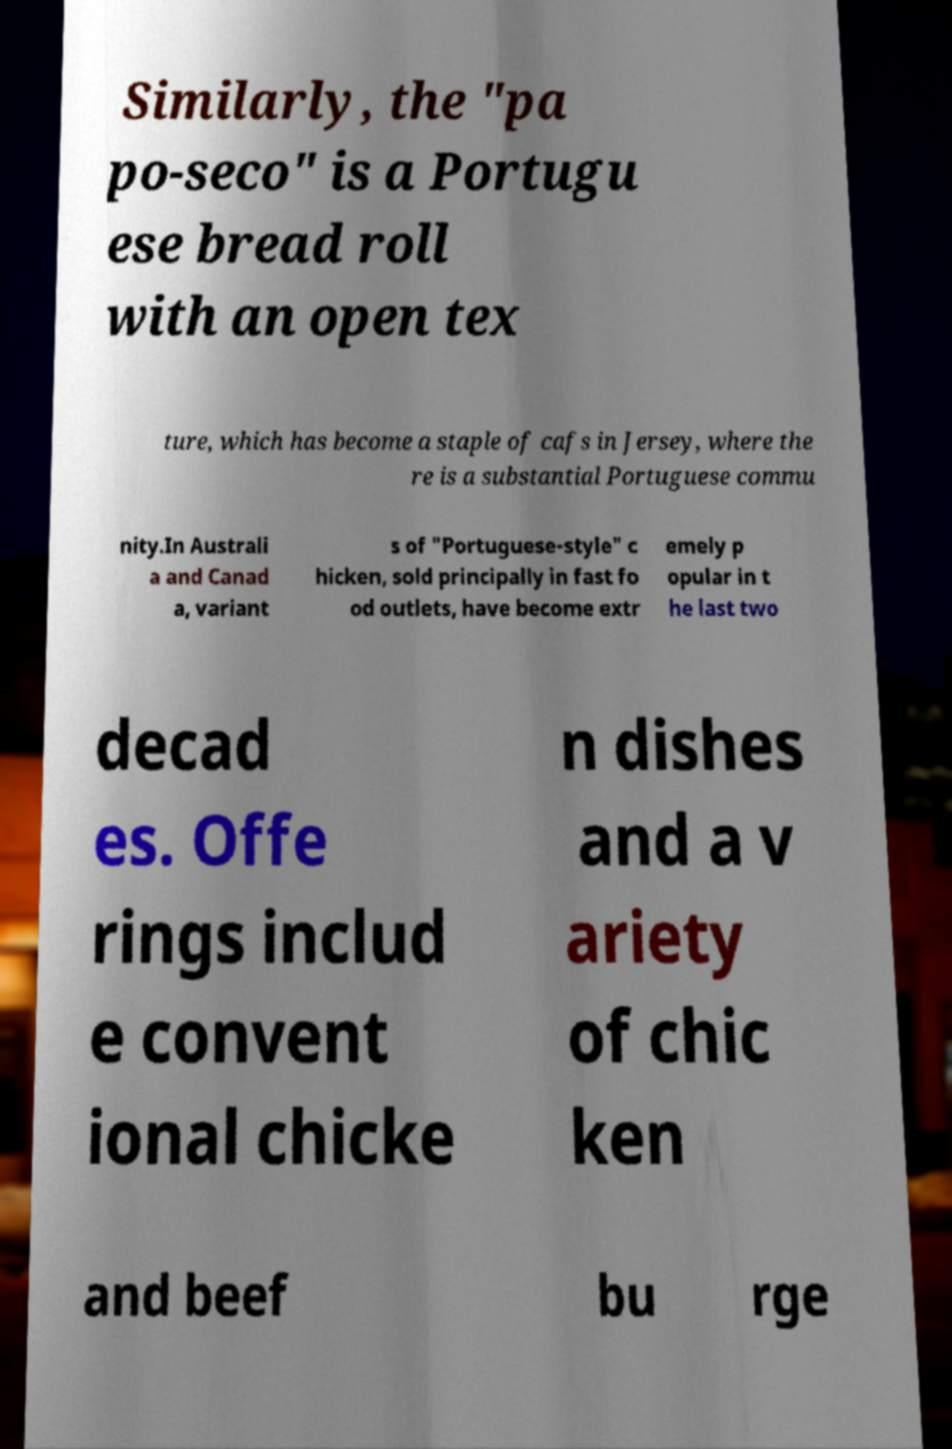Please identify and transcribe the text found in this image. Similarly, the "pa po-seco" is a Portugu ese bread roll with an open tex ture, which has become a staple of cafs in Jersey, where the re is a substantial Portuguese commu nity.In Australi a and Canad a, variant s of "Portuguese-style" c hicken, sold principally in fast fo od outlets, have become extr emely p opular in t he last two decad es. Offe rings includ e convent ional chicke n dishes and a v ariety of chic ken and beef bu rge 